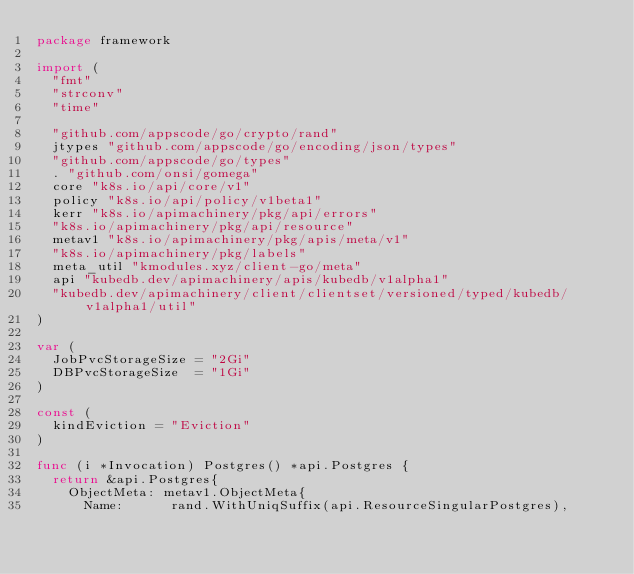Convert code to text. <code><loc_0><loc_0><loc_500><loc_500><_Go_>package framework

import (
	"fmt"
	"strconv"
	"time"

	"github.com/appscode/go/crypto/rand"
	jtypes "github.com/appscode/go/encoding/json/types"
	"github.com/appscode/go/types"
	. "github.com/onsi/gomega"
	core "k8s.io/api/core/v1"
	policy "k8s.io/api/policy/v1beta1"
	kerr "k8s.io/apimachinery/pkg/api/errors"
	"k8s.io/apimachinery/pkg/api/resource"
	metav1 "k8s.io/apimachinery/pkg/apis/meta/v1"
	"k8s.io/apimachinery/pkg/labels"
	meta_util "kmodules.xyz/client-go/meta"
	api "kubedb.dev/apimachinery/apis/kubedb/v1alpha1"
	"kubedb.dev/apimachinery/client/clientset/versioned/typed/kubedb/v1alpha1/util"
)

var (
	JobPvcStorageSize = "2Gi"
	DBPvcStorageSize  = "1Gi"
)

const (
	kindEviction = "Eviction"
)

func (i *Invocation) Postgres() *api.Postgres {
	return &api.Postgres{
		ObjectMeta: metav1.ObjectMeta{
			Name:      rand.WithUniqSuffix(api.ResourceSingularPostgres),</code> 